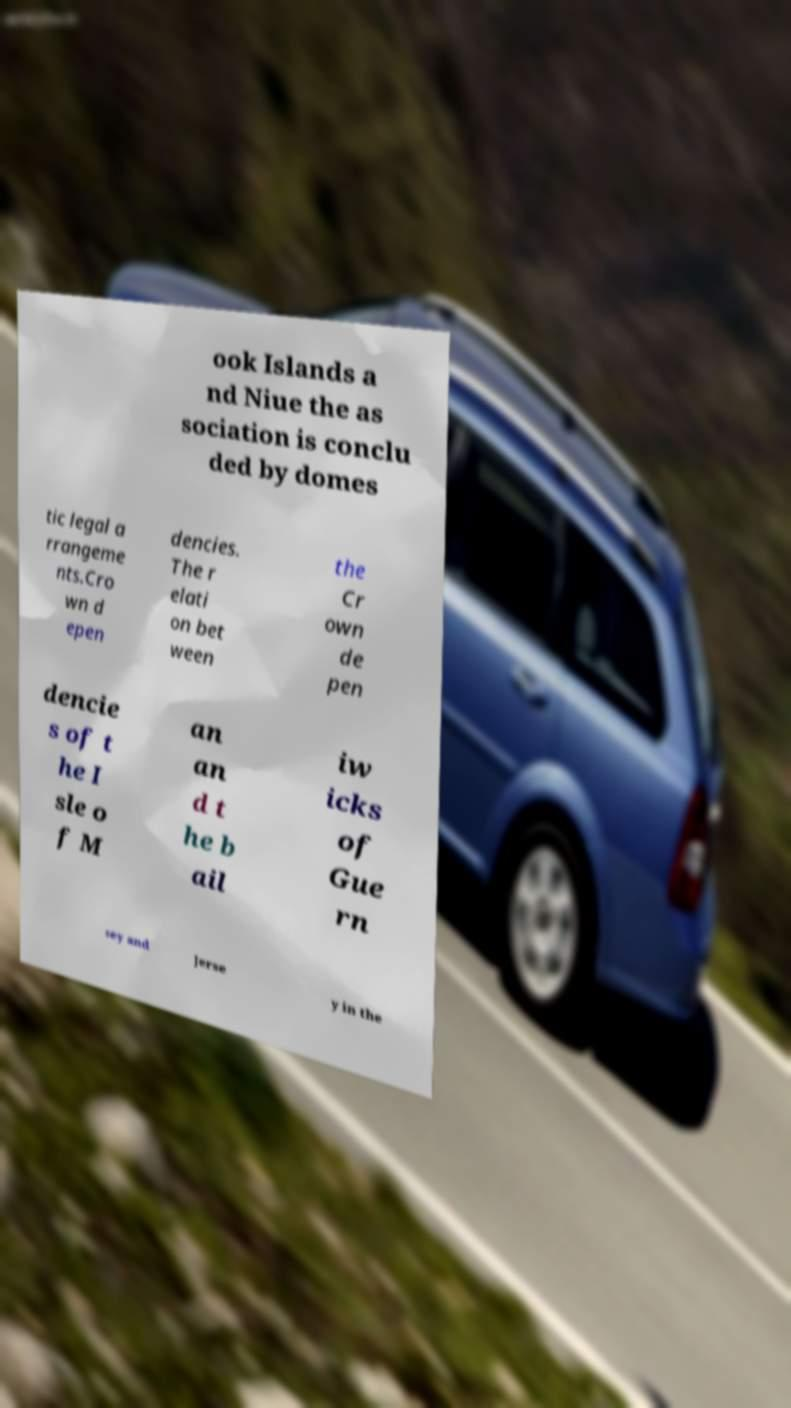I need the written content from this picture converted into text. Can you do that? ook Islands a nd Niue the as sociation is conclu ded by domes tic legal a rrangeme nts.Cro wn d epen dencies. The r elati on bet ween the Cr own de pen dencie s of t he I sle o f M an an d t he b ail iw icks of Gue rn sey and Jerse y in the 